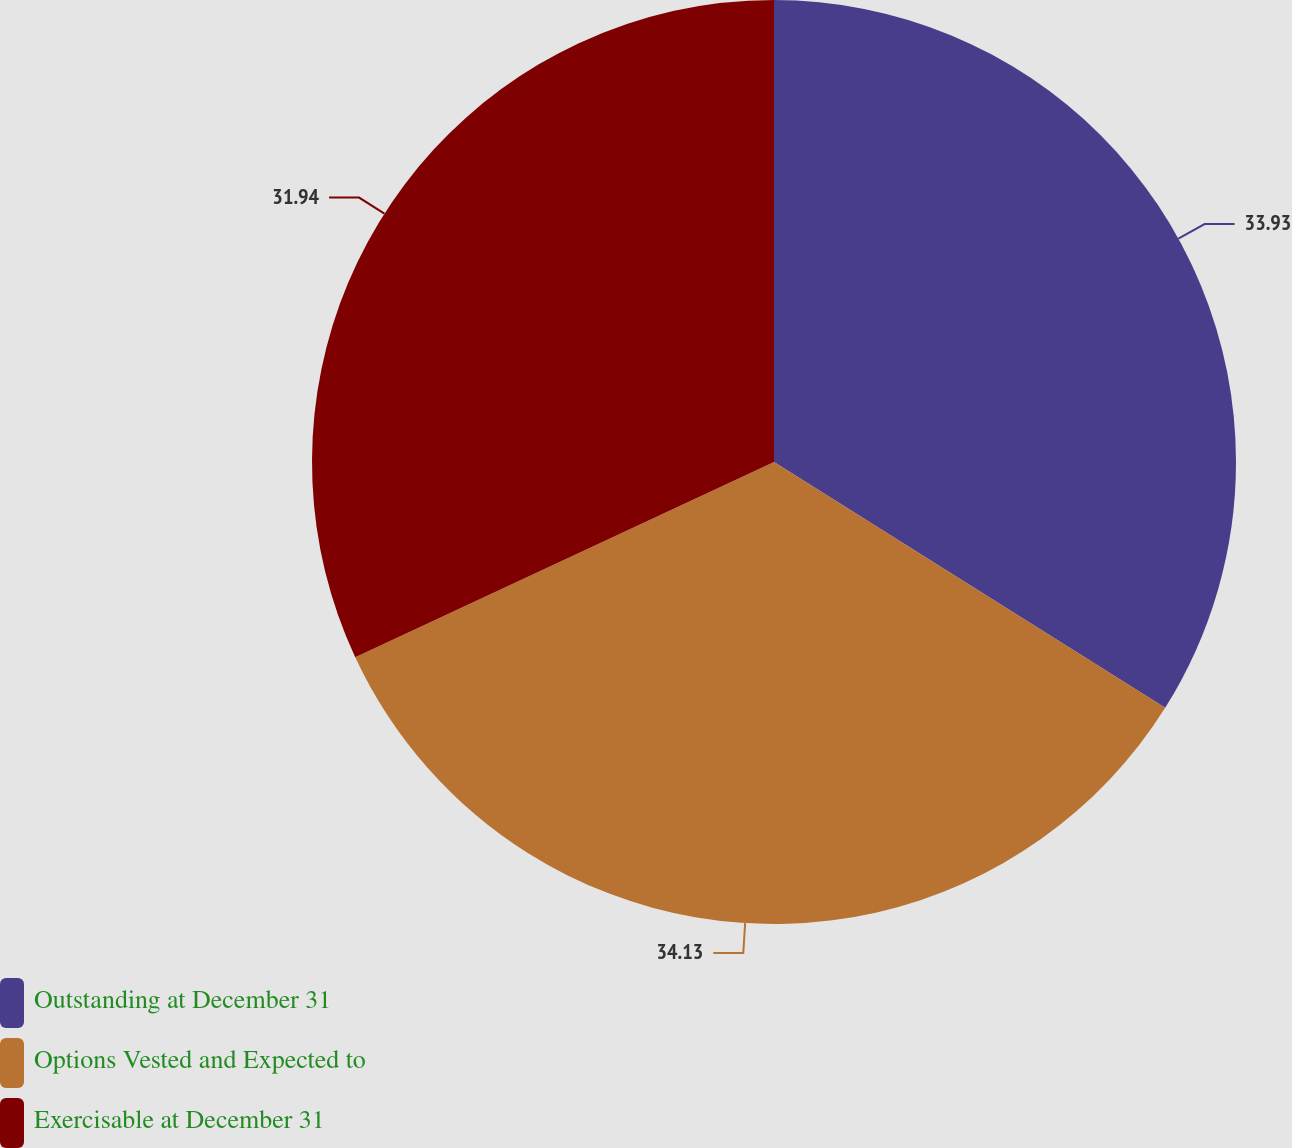Convert chart. <chart><loc_0><loc_0><loc_500><loc_500><pie_chart><fcel>Outstanding at December 31<fcel>Options Vested and Expected to<fcel>Exercisable at December 31<nl><fcel>33.93%<fcel>34.13%<fcel>31.94%<nl></chart> 